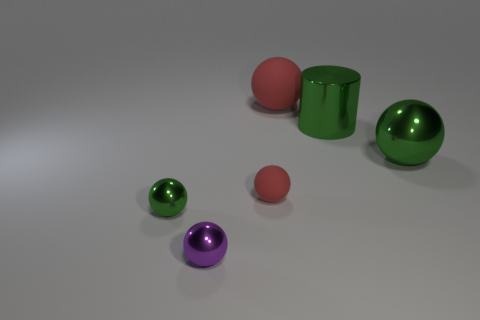Add 3 small things. How many objects exist? 9 Subtract all purple spheres. How many spheres are left? 4 Subtract all green metallic spheres. How many spheres are left? 3 Subtract 0 cyan cylinders. How many objects are left? 6 Subtract all spheres. How many objects are left? 1 Subtract 2 balls. How many balls are left? 3 Subtract all blue balls. Subtract all purple cylinders. How many balls are left? 5 Subtract all yellow cylinders. How many red balls are left? 2 Subtract all big purple objects. Subtract all small matte objects. How many objects are left? 5 Add 6 tiny purple metallic balls. How many tiny purple metallic balls are left? 7 